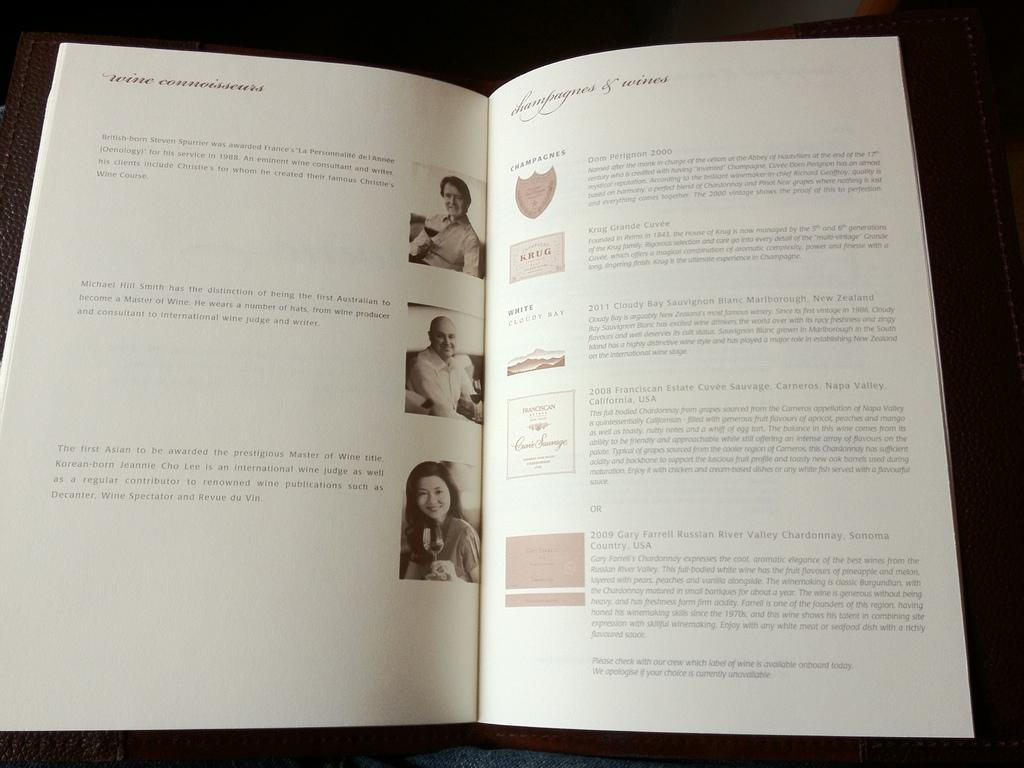Provide a one-sentence caption for the provided image. A wine book with opinions from different wine connoisseurs. 